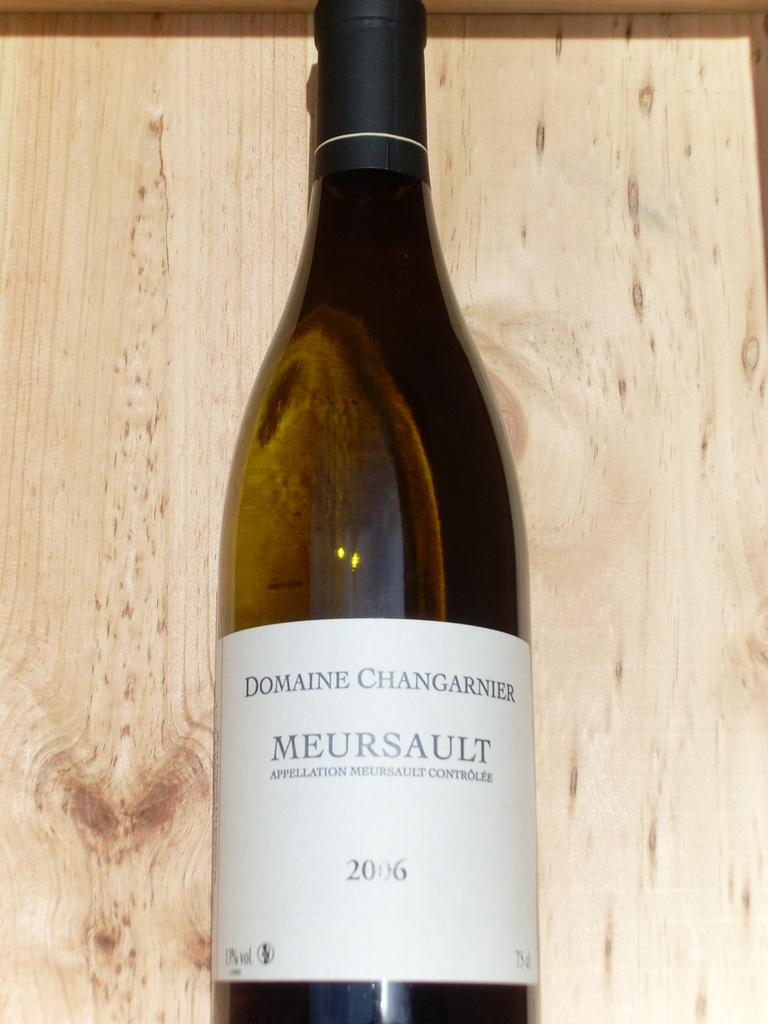<image>
Present a compact description of the photo's key features. The bottle of Meursault was made in 2006. 